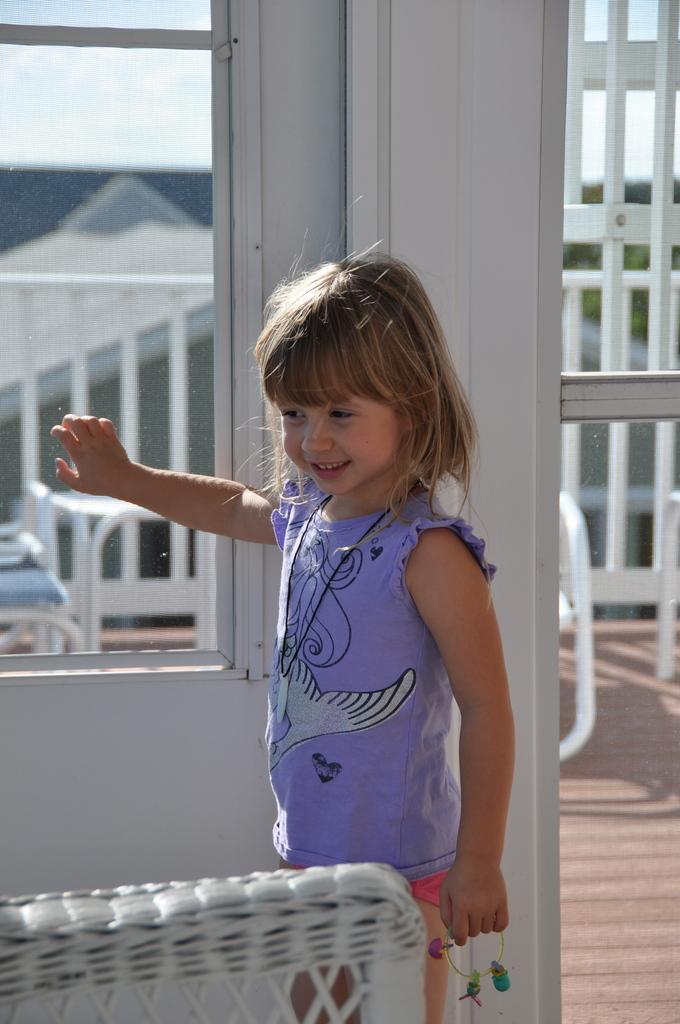Could you give a brief overview of what you see in this image? In this image there is a kid standing and smiling, and in the background there are chairs, table, iron grills, house,sky. 